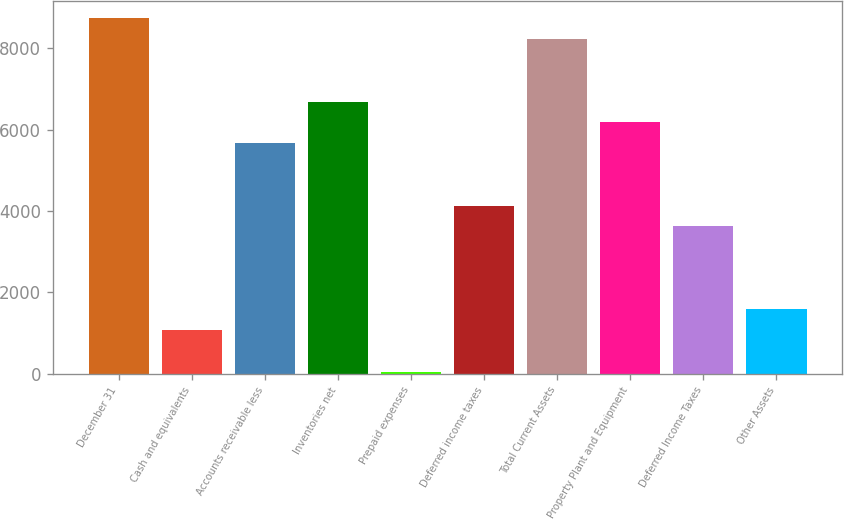Convert chart to OTSL. <chart><loc_0><loc_0><loc_500><loc_500><bar_chart><fcel>December 31<fcel>Cash and equivalents<fcel>Accounts receivable less<fcel>Inventories net<fcel>Prepaid expenses<fcel>Deferred income taxes<fcel>Total Current Assets<fcel>Property Plant and Equipment<fcel>Deferred Income Taxes<fcel>Other Assets<nl><fcel>8734.75<fcel>1066<fcel>5667.25<fcel>6689.75<fcel>43.5<fcel>4133.5<fcel>8223.5<fcel>6178.5<fcel>3622.25<fcel>1577.25<nl></chart> 